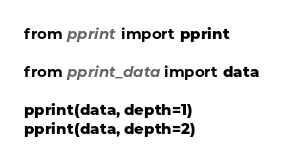<code> <loc_0><loc_0><loc_500><loc_500><_Python_>from pprint import pprint

from pprint_data import data

pprint(data, depth=1)
pprint(data, depth=2)</code> 